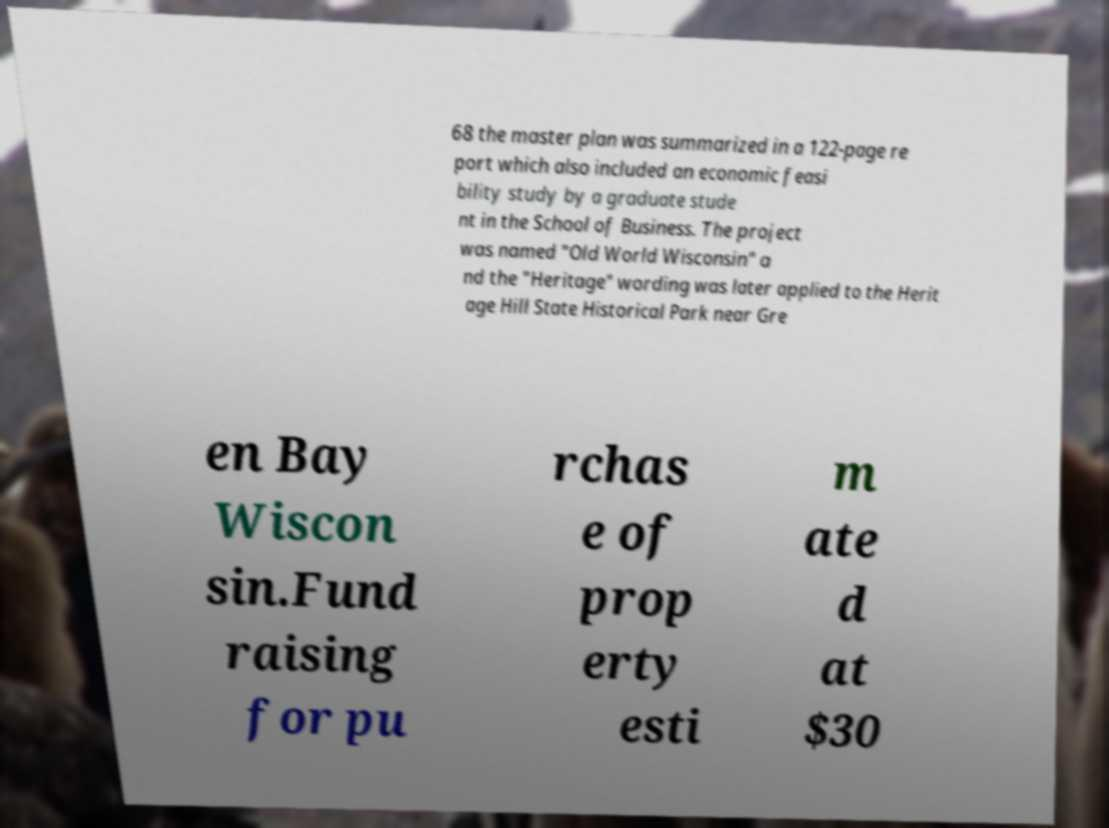I need the written content from this picture converted into text. Can you do that? 68 the master plan was summarized in a 122-page re port which also included an economic feasi bility study by a graduate stude nt in the School of Business. The project was named "Old World Wisconsin" a nd the "Heritage" wording was later applied to the Herit age Hill State Historical Park near Gre en Bay Wiscon sin.Fund raising for pu rchas e of prop erty esti m ate d at $30 